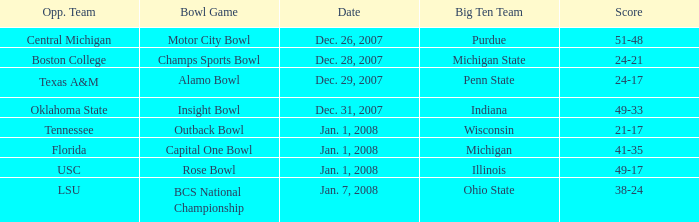What bowl game was played on Dec. 26, 2007? Motor City Bowl. Help me parse the entirety of this table. {'header': ['Opp. Team', 'Bowl Game', 'Date', 'Big Ten Team', 'Score'], 'rows': [['Central Michigan', 'Motor City Bowl', 'Dec. 26, 2007', 'Purdue', '51-48'], ['Boston College', 'Champs Sports Bowl', 'Dec. 28, 2007', 'Michigan State', '24-21'], ['Texas A&M', 'Alamo Bowl', 'Dec. 29, 2007', 'Penn State', '24-17'], ['Oklahoma State', 'Insight Bowl', 'Dec. 31, 2007', 'Indiana', '49-33'], ['Tennessee', 'Outback Bowl', 'Jan. 1, 2008', 'Wisconsin', '21-17'], ['Florida', 'Capital One Bowl', 'Jan. 1, 2008', 'Michigan', '41-35'], ['USC', 'Rose Bowl', 'Jan. 1, 2008', 'Illinois', '49-17'], ['LSU', 'BCS National Championship', 'Jan. 7, 2008', 'Ohio State', '38-24']]} 